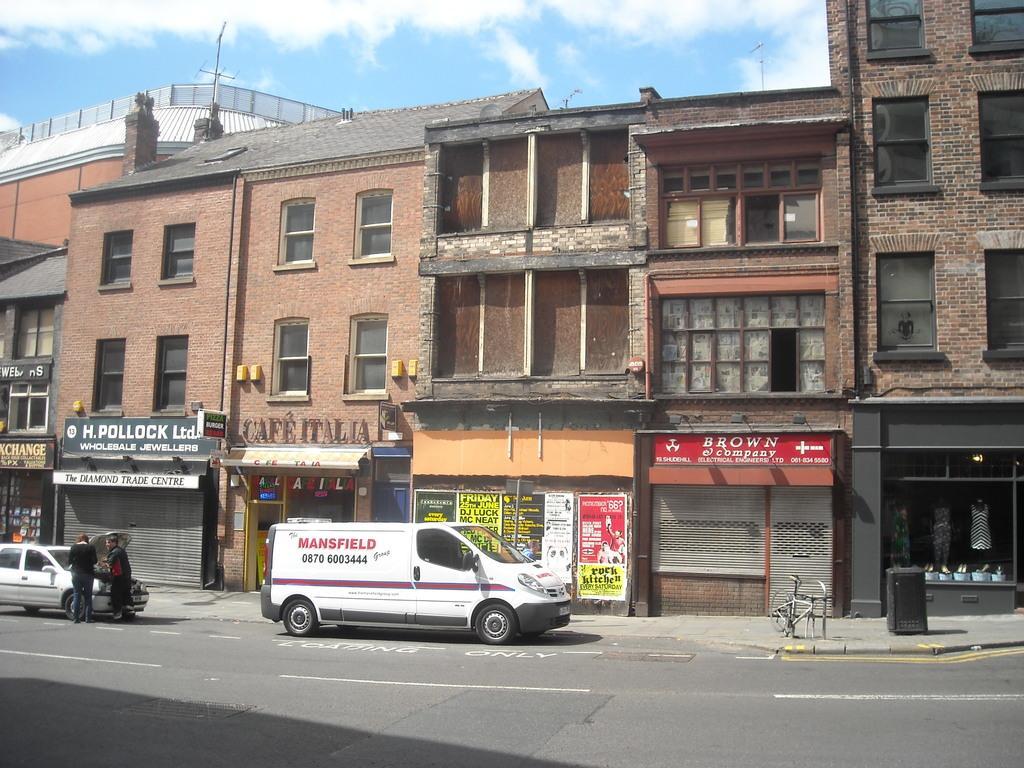How would you summarize this image in a sentence or two? In this image there are buildings. At the bottom there are vehicles on the road. On the left there are two people. In the background there is sky. 